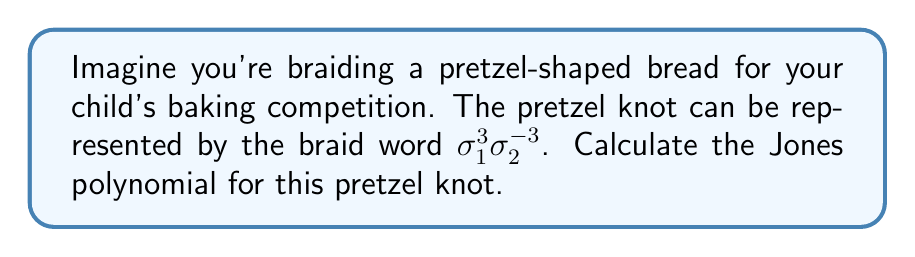Can you solve this math problem? Let's approach this step-by-step:

1) First, we need to convert the braid word to a closure diagram. The braid $\sigma_1^3\sigma_2^{-3}$ represents a 3-strand braid where the first strand crosses over the second three times, then the third strand crosses over the second three times.

2) To calculate the Jones polynomial, we'll use the Kauffman bracket polynomial and then normalize it.

3) The Kauffman bracket satisfies these relations:
   $$\langle \crossingA \rangle = A\langle \smoothingA \rangle + A^{-1}\langle \smoothingB \rangle$$
   $$\langle O \cup K \rangle = (-A^2 - A^{-2})\langle K \rangle$$
   $$\langle O \rangle = 1$$

4) Starting with $\sigma_1^3$:
   $$\langle \sigma_1^3 \rangle = A^3\langle III \rangle + 3A\langle )( \rangle + 3A^{-1}\langle ( ) \rangle + A^{-3}\langle \rangle$$

5) Then for $\sigma_2^{-3}$:
   $$\langle \sigma_2^{-3} \rangle = A^{-3}\langle III \rangle + 3A^{-1}\langle )( \rangle + 3A\langle ( ) \rangle + A^3\langle \rangle$$

6) Combining these:
   $$\langle \sigma_1^3\sigma_2^{-3} \rangle = A^0 + 3A^{-2}(-A^2-A^{-2}) + 3A^2(-A^2-A^{-2}) + A^6 + A^{-6}$$

7) Simplifying:
   $$\langle \sigma_1^3\sigma_2^{-3} \rangle = 1 - 3A^4 - 3A^{-4} - 3A^0 - 3A^0 + A^6 + A^{-6}$$
   $$= A^6 + A^{-6} - 3A^4 - 3A^{-4} - 5$$

8) The writhe of this knot is 0, so the normalization factor is $(-A^3)^0 = 1$.

9) Substituting $A = t^{-1/4}$, we get the Jones polynomial:
   $$V(t) = t^{-3/2} + t^{3/2} - 3t^{-1} - 3t - 5$$
Answer: $t^{-3/2} + t^{3/2} - 3t^{-1} - 3t - 5$ 